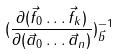<formula> <loc_0><loc_0><loc_500><loc_500>( \frac { \partial ( \vec { f } _ { 0 } \dots \vec { f } _ { k } ) } { \partial ( \vec { a } _ { 0 } \dots \vec { a } _ { n } ) } ) _ { \vec { b } } ^ { - 1 }</formula> 